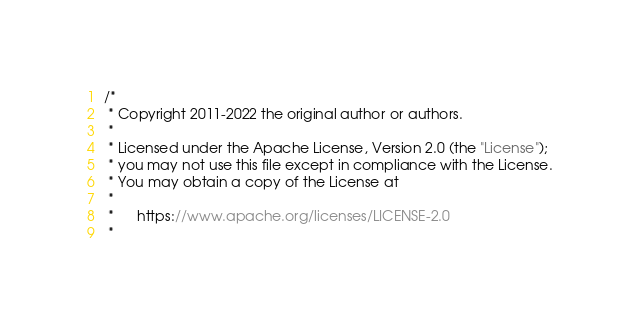Convert code to text. <code><loc_0><loc_0><loc_500><loc_500><_Java_>/*
 * Copyright 2011-2022 the original author or authors.
 *
 * Licensed under the Apache License, Version 2.0 (the "License");
 * you may not use this file except in compliance with the License.
 * You may obtain a copy of the License at
 *
 *      https://www.apache.org/licenses/LICENSE-2.0
 *</code> 